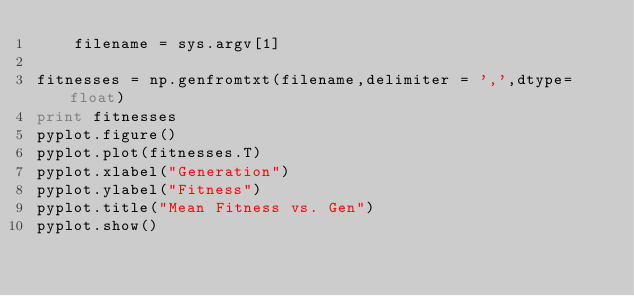Convert code to text. <code><loc_0><loc_0><loc_500><loc_500><_Python_>    filename = sys.argv[1]
    
fitnesses = np.genfromtxt(filename,delimiter = ',',dtype=float)
print fitnesses
pyplot.figure()
pyplot.plot(fitnesses.T)
pyplot.xlabel("Generation")
pyplot.ylabel("Fitness")
pyplot.title("Mean Fitness vs. Gen")
pyplot.show()
</code> 